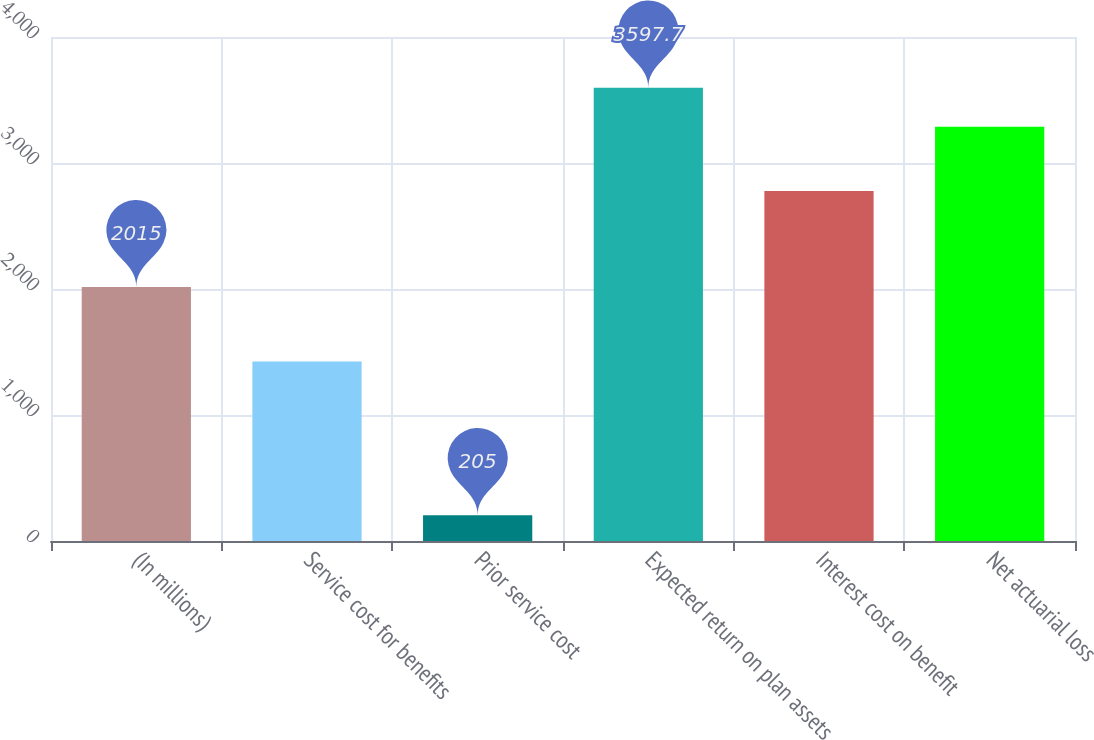Convert chart to OTSL. <chart><loc_0><loc_0><loc_500><loc_500><bar_chart><fcel>(In millions)<fcel>Service cost for benefits<fcel>Prior service cost<fcel>Expected return on plan assets<fcel>Interest cost on benefit<fcel>Net actuarial loss<nl><fcel>2015<fcel>1424<fcel>205<fcel>3597.7<fcel>2778<fcel>3288<nl></chart> 